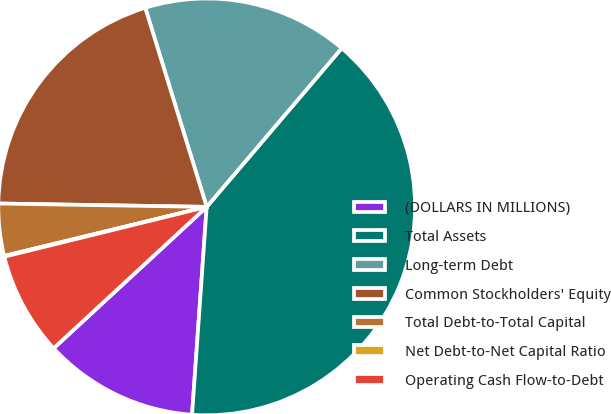Convert chart. <chart><loc_0><loc_0><loc_500><loc_500><pie_chart><fcel>(DOLLARS IN MILLIONS)<fcel>Total Assets<fcel>Long-term Debt<fcel>Common Stockholders' Equity<fcel>Total Debt-to-Total Capital<fcel>Net Debt-to-Net Capital Ratio<fcel>Operating Cash Flow-to-Debt<nl><fcel>12.01%<fcel>39.9%<fcel>15.99%<fcel>19.98%<fcel>4.04%<fcel>0.06%<fcel>8.03%<nl></chart> 